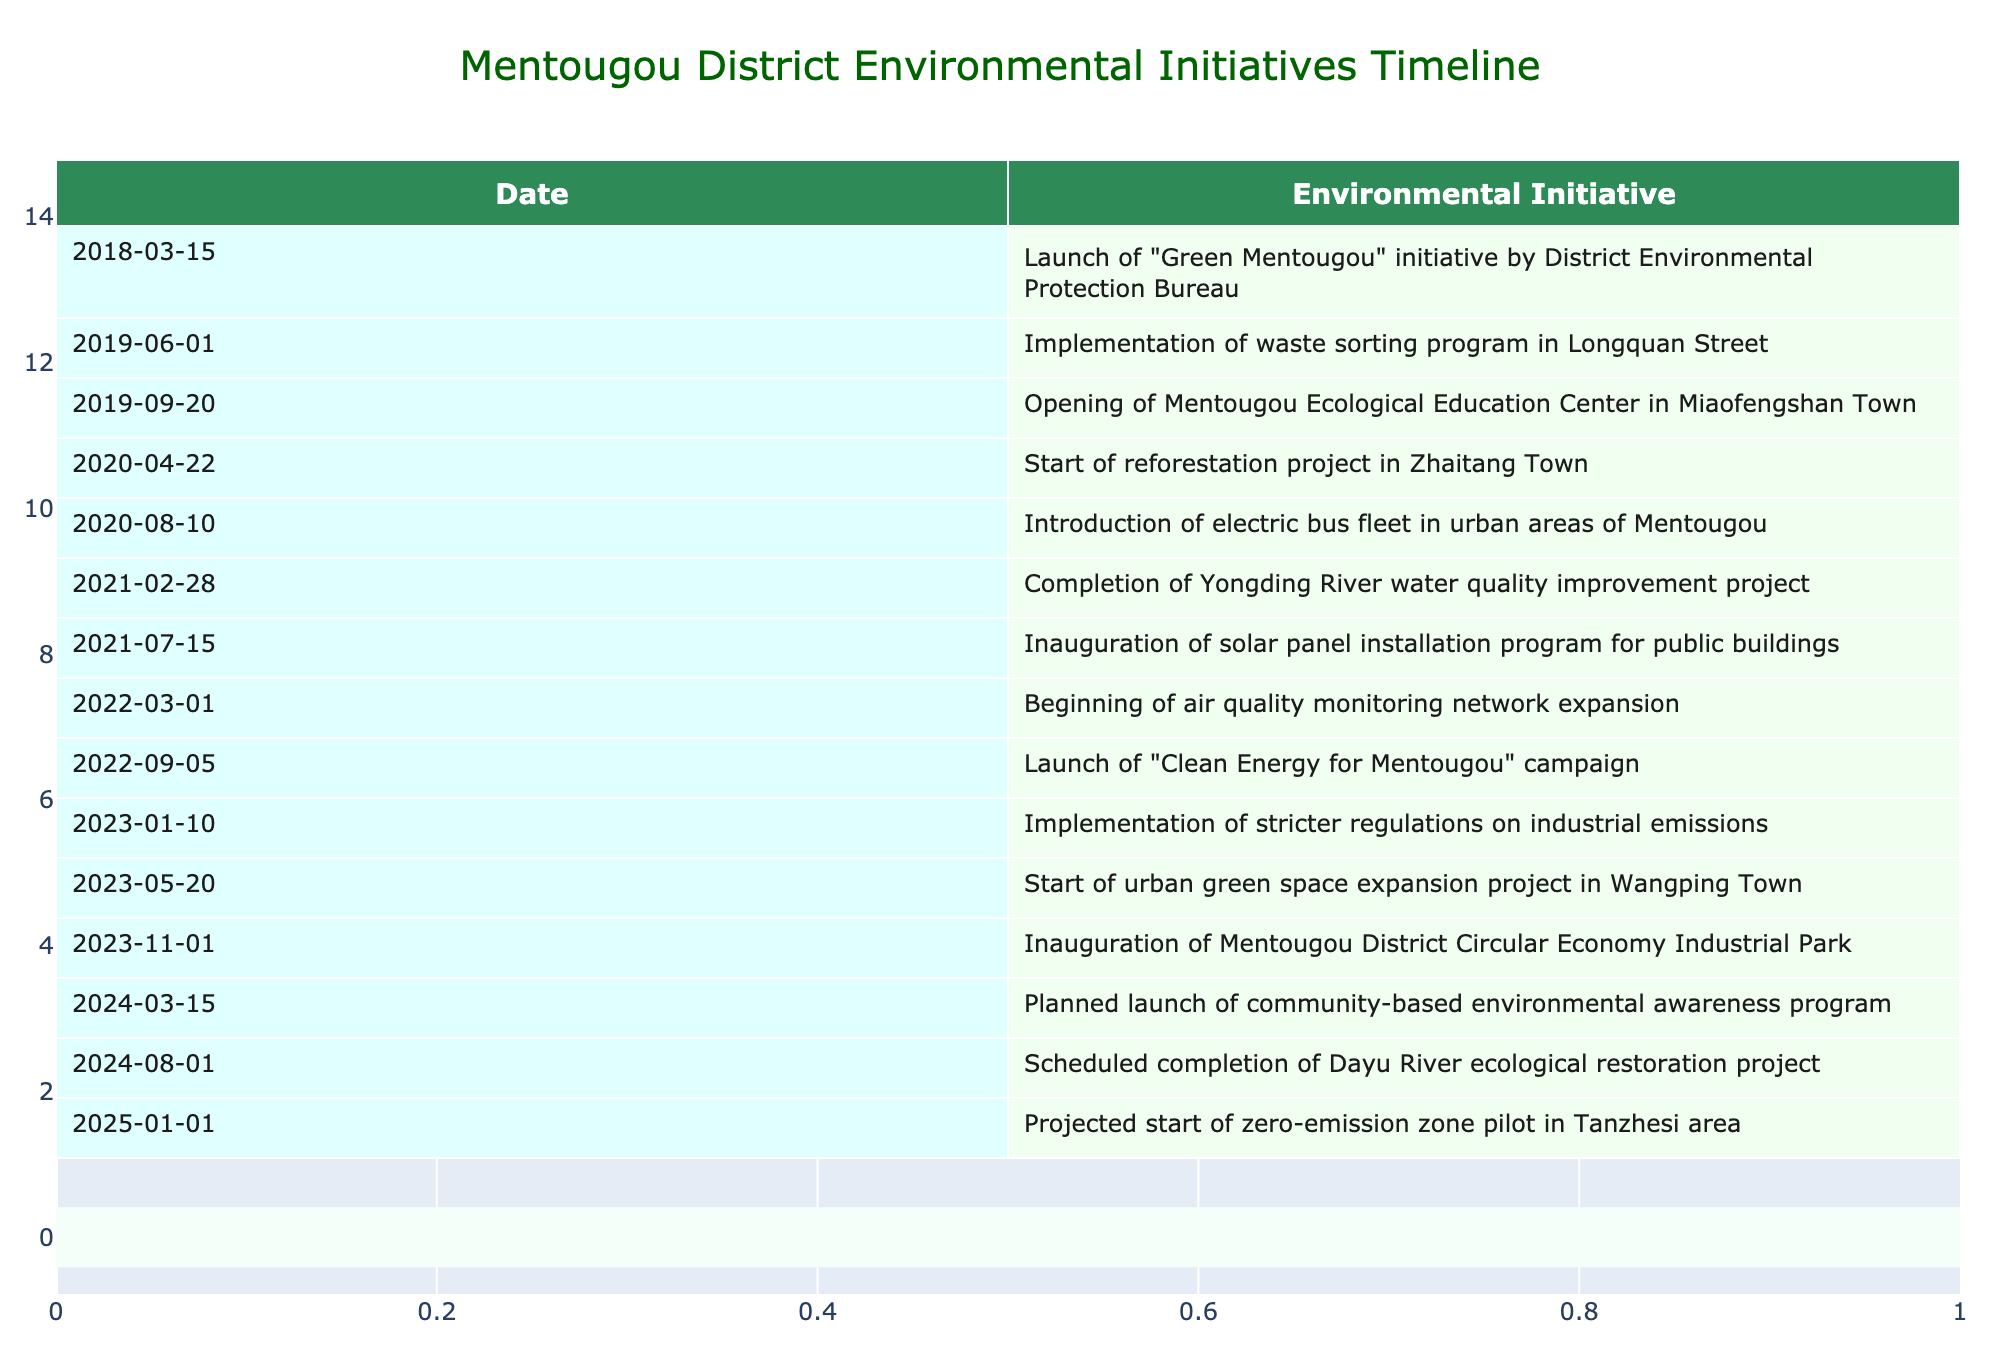What date was the "Green Mentougou" initiative launched? The row in the table corresponding to the "Green Mentougou" initiative shows the date as 2018-03-15.
Answer: 2018-03-15 How many initiatives were launched in 2020? In 2020, there are three initiatives listed: the reforestation project (April 22), the electric bus fleet introduction (August 10), and another initiative not mentioned until 2021. Therefore, only two of them pertain to 2020.
Answer: 2 What is the latest event listed in the table? The most recent date in the table is 2025-01-01, which corresponds to the projected start of the zero-emission zone pilot in the Tanzhesi area.
Answer: 2025-01-01 Did the District Environmental Protection Bureau launch any initiatives in 2021? Yes, there are two initiatives in 2021: the completion of the Yongding River water quality improvement project on February 28 and the inauguration of the solar panel installation program on July 15.
Answer: Yes Which event took place first: the opening of the Mentougou Ecological Education Center or the implementation of the waste sorting program? The implementation of the waste sorting program took place on June 1, 2019, while the opening of the Mentougou Ecological Education Center occurred later on September 20, 2019. Therefore, the waste sorting program occurred first.
Answer: Waste sorting program How many total events are scheduled for 2024? The table shows two events scheduled for 2024: the launch of the community-based environmental awareness program on March 15 and the completion of the Dayu River ecological restoration project on August 1.
Answer: 2 Was there an initiative focused on air quality monitoring? Yes, there was an initiative focusing on air quality monitoring, which started on March 1, 2022.
Answer: Yes Which month had the highest number of scheduled events according to the table? Reviewing the entire table, no month appears to have more than two events scheduled. Each month includes either one or two initiatives. Thus, the highest frequency for any month is two events, found in various months like March and August in different years. Since the maximum is equal, there’s no specific month with more: March 1 and August 10.
Answer: March and August 